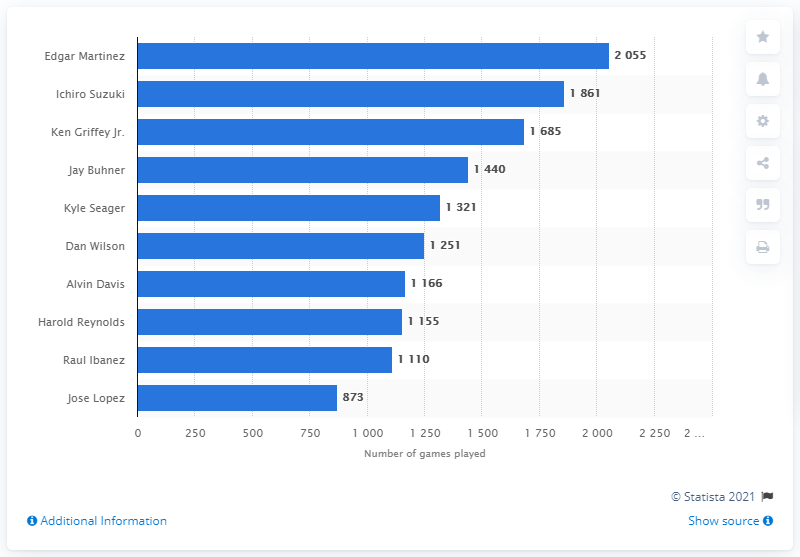Identify some key points in this picture. Edgar Martinez, the Seattle Mariners franchise's record holder, has played the most games in team history. 